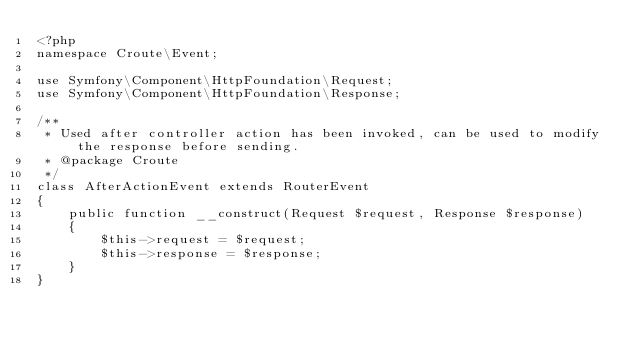<code> <loc_0><loc_0><loc_500><loc_500><_PHP_><?php
namespace Croute\Event;

use Symfony\Component\HttpFoundation\Request;
use Symfony\Component\HttpFoundation\Response;

/**
 * Used after controller action has been invoked, can be used to modify the response before sending.
 * @package Croute
 */
class AfterActionEvent extends RouterEvent
{
    public function __construct(Request $request, Response $response)
    {
        $this->request = $request;
        $this->response = $response;
    }
}
</code> 